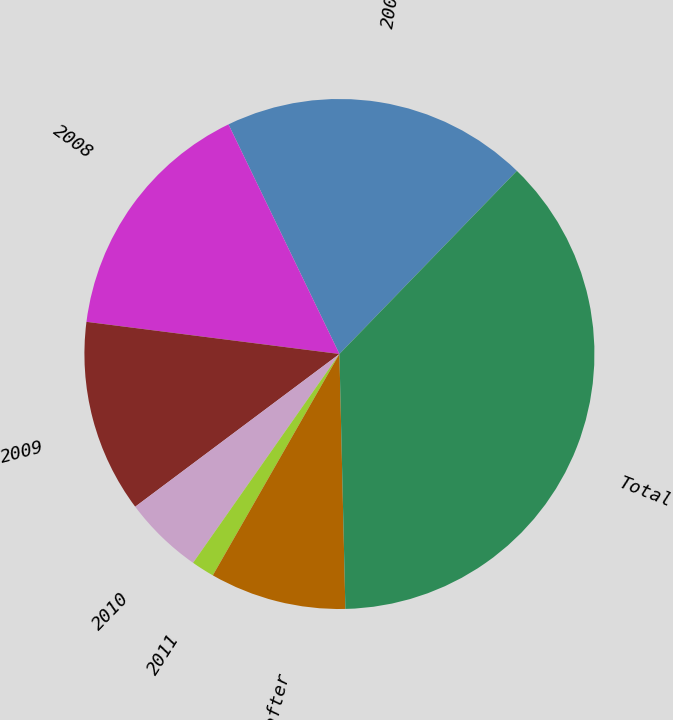Convert chart to OTSL. <chart><loc_0><loc_0><loc_500><loc_500><pie_chart><fcel>2007<fcel>2008<fcel>2009<fcel>2010<fcel>2011<fcel>2012 and thereafter<fcel>Total<nl><fcel>19.41%<fcel>15.82%<fcel>12.23%<fcel>5.05%<fcel>1.46%<fcel>8.64%<fcel>37.37%<nl></chart> 